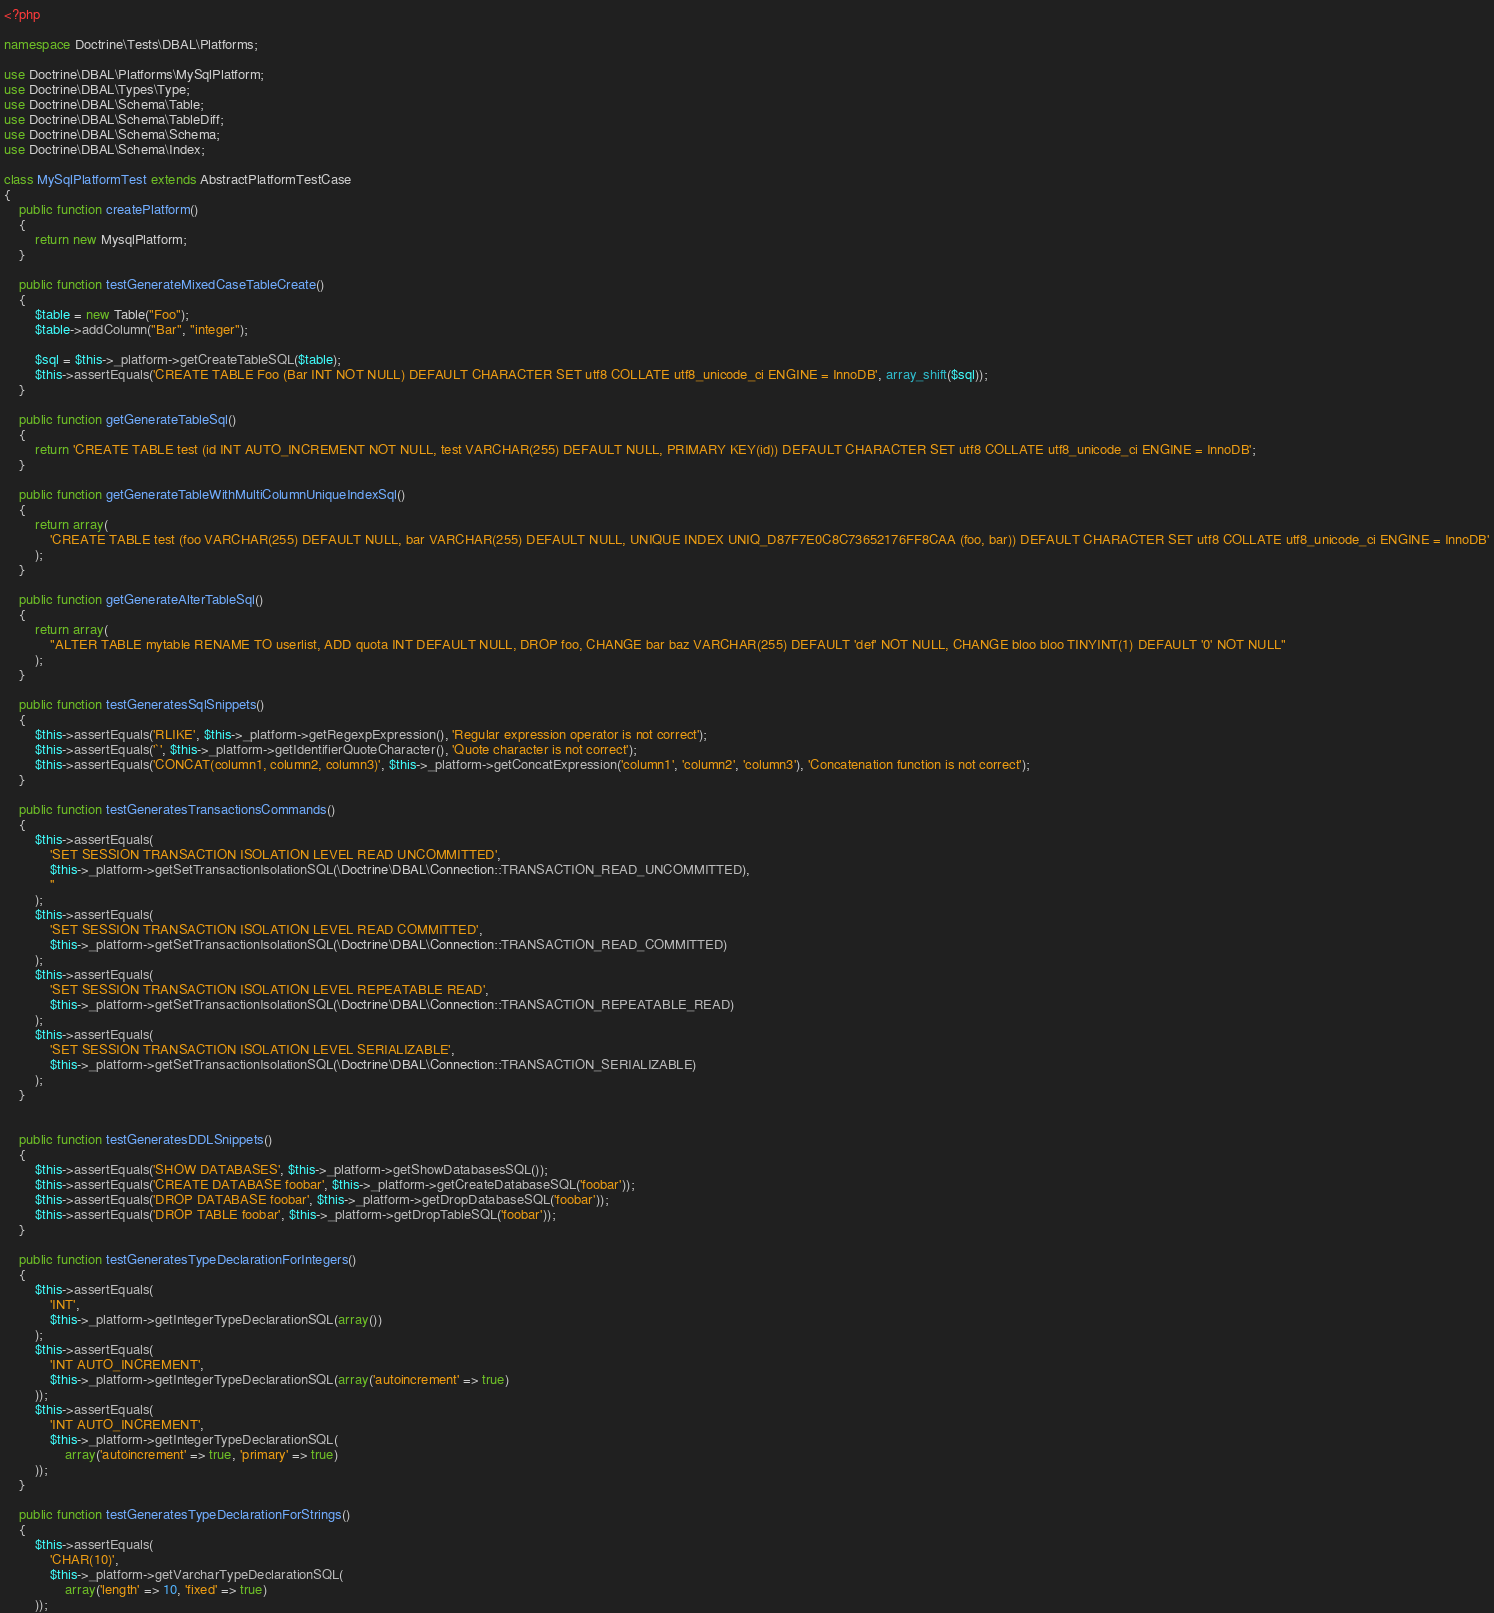<code> <loc_0><loc_0><loc_500><loc_500><_PHP_><?php

namespace Doctrine\Tests\DBAL\Platforms;

use Doctrine\DBAL\Platforms\MySqlPlatform;
use Doctrine\DBAL\Types\Type;
use Doctrine\DBAL\Schema\Table;
use Doctrine\DBAL\Schema\TableDiff;
use Doctrine\DBAL\Schema\Schema;
use Doctrine\DBAL\Schema\Index;

class MySqlPlatformTest extends AbstractPlatformTestCase
{
    public function createPlatform()
    {
        return new MysqlPlatform;
    }

    public function testGenerateMixedCaseTableCreate()
    {
        $table = new Table("Foo");
        $table->addColumn("Bar", "integer");

        $sql = $this->_platform->getCreateTableSQL($table);
        $this->assertEquals('CREATE TABLE Foo (Bar INT NOT NULL) DEFAULT CHARACTER SET utf8 COLLATE utf8_unicode_ci ENGINE = InnoDB', array_shift($sql));
    }

    public function getGenerateTableSql()
    {
        return 'CREATE TABLE test (id INT AUTO_INCREMENT NOT NULL, test VARCHAR(255) DEFAULT NULL, PRIMARY KEY(id)) DEFAULT CHARACTER SET utf8 COLLATE utf8_unicode_ci ENGINE = InnoDB';
    }

    public function getGenerateTableWithMultiColumnUniqueIndexSql()
    {
        return array(
            'CREATE TABLE test (foo VARCHAR(255) DEFAULT NULL, bar VARCHAR(255) DEFAULT NULL, UNIQUE INDEX UNIQ_D87F7E0C8C73652176FF8CAA (foo, bar)) DEFAULT CHARACTER SET utf8 COLLATE utf8_unicode_ci ENGINE = InnoDB'
        );
    }

    public function getGenerateAlterTableSql()
    {
        return array(
            "ALTER TABLE mytable RENAME TO userlist, ADD quota INT DEFAULT NULL, DROP foo, CHANGE bar baz VARCHAR(255) DEFAULT 'def' NOT NULL, CHANGE bloo bloo TINYINT(1) DEFAULT '0' NOT NULL"
        );
    }

    public function testGeneratesSqlSnippets()
    {
        $this->assertEquals('RLIKE', $this->_platform->getRegexpExpression(), 'Regular expression operator is not correct');
        $this->assertEquals('`', $this->_platform->getIdentifierQuoteCharacter(), 'Quote character is not correct');
        $this->assertEquals('CONCAT(column1, column2, column3)', $this->_platform->getConcatExpression('column1', 'column2', 'column3'), 'Concatenation function is not correct');
    }

    public function testGeneratesTransactionsCommands()
    {
        $this->assertEquals(
            'SET SESSION TRANSACTION ISOLATION LEVEL READ UNCOMMITTED',
            $this->_platform->getSetTransactionIsolationSQL(\Doctrine\DBAL\Connection::TRANSACTION_READ_UNCOMMITTED),
            ''
        );
        $this->assertEquals(
            'SET SESSION TRANSACTION ISOLATION LEVEL READ COMMITTED',
            $this->_platform->getSetTransactionIsolationSQL(\Doctrine\DBAL\Connection::TRANSACTION_READ_COMMITTED)
        );
        $this->assertEquals(
            'SET SESSION TRANSACTION ISOLATION LEVEL REPEATABLE READ',
            $this->_platform->getSetTransactionIsolationSQL(\Doctrine\DBAL\Connection::TRANSACTION_REPEATABLE_READ)
        );
        $this->assertEquals(
            'SET SESSION TRANSACTION ISOLATION LEVEL SERIALIZABLE',
            $this->_platform->getSetTransactionIsolationSQL(\Doctrine\DBAL\Connection::TRANSACTION_SERIALIZABLE)
        );
    }


    public function testGeneratesDDLSnippets()
    {
        $this->assertEquals('SHOW DATABASES', $this->_platform->getShowDatabasesSQL());
        $this->assertEquals('CREATE DATABASE foobar', $this->_platform->getCreateDatabaseSQL('foobar'));
        $this->assertEquals('DROP DATABASE foobar', $this->_platform->getDropDatabaseSQL('foobar'));
        $this->assertEquals('DROP TABLE foobar', $this->_platform->getDropTableSQL('foobar'));
    }

    public function testGeneratesTypeDeclarationForIntegers()
    {
        $this->assertEquals(
            'INT',
            $this->_platform->getIntegerTypeDeclarationSQL(array())
        );
        $this->assertEquals(
            'INT AUTO_INCREMENT',
            $this->_platform->getIntegerTypeDeclarationSQL(array('autoincrement' => true)
        ));
        $this->assertEquals(
            'INT AUTO_INCREMENT',
            $this->_platform->getIntegerTypeDeclarationSQL(
                array('autoincrement' => true, 'primary' => true)
        ));
    }

    public function testGeneratesTypeDeclarationForStrings()
    {
        $this->assertEquals(
            'CHAR(10)',
            $this->_platform->getVarcharTypeDeclarationSQL(
                array('length' => 10, 'fixed' => true)
        ));</code> 